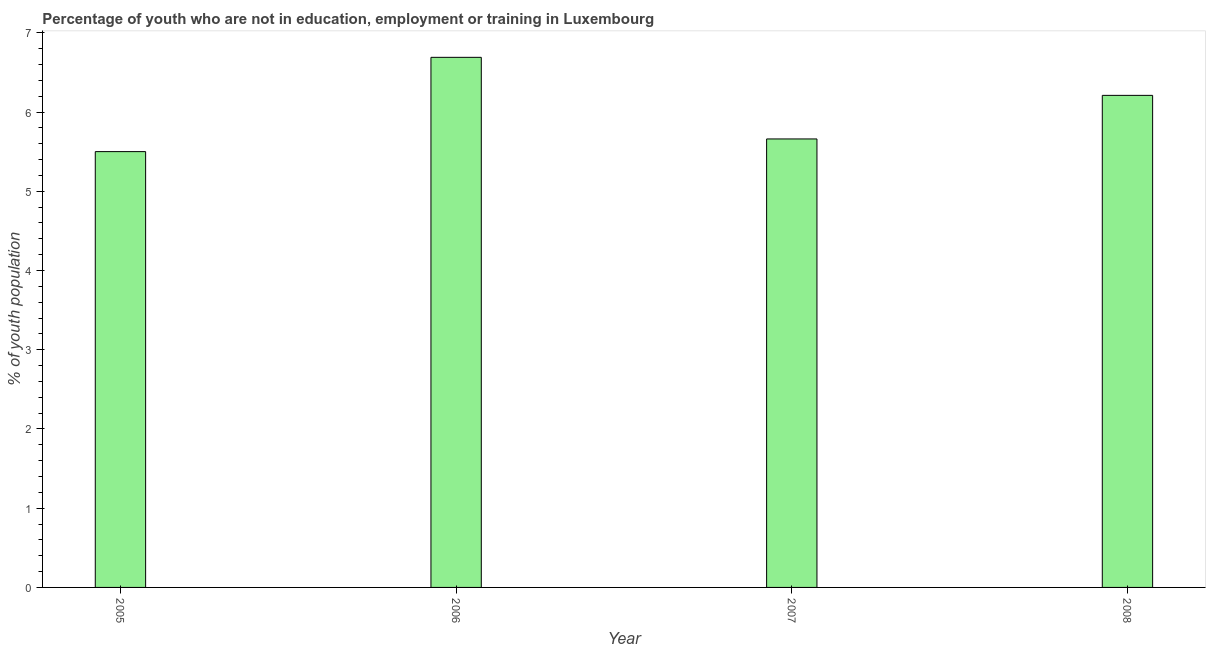Does the graph contain any zero values?
Your response must be concise. No. Does the graph contain grids?
Your answer should be very brief. No. What is the title of the graph?
Provide a short and direct response. Percentage of youth who are not in education, employment or training in Luxembourg. What is the label or title of the X-axis?
Ensure brevity in your answer.  Year. What is the label or title of the Y-axis?
Keep it short and to the point. % of youth population. What is the unemployed youth population in 2008?
Make the answer very short. 6.21. Across all years, what is the maximum unemployed youth population?
Your response must be concise. 6.69. In which year was the unemployed youth population minimum?
Offer a very short reply. 2005. What is the sum of the unemployed youth population?
Your response must be concise. 24.06. What is the difference between the unemployed youth population in 2006 and 2008?
Offer a terse response. 0.48. What is the average unemployed youth population per year?
Your answer should be compact. 6.01. What is the median unemployed youth population?
Give a very brief answer. 5.93. In how many years, is the unemployed youth population greater than 4.6 %?
Provide a succinct answer. 4. Do a majority of the years between 2008 and 2005 (inclusive) have unemployed youth population greater than 4.2 %?
Offer a very short reply. Yes. What is the ratio of the unemployed youth population in 2006 to that in 2008?
Provide a short and direct response. 1.08. Is the unemployed youth population in 2005 less than that in 2006?
Keep it short and to the point. Yes. Is the difference between the unemployed youth population in 2005 and 2006 greater than the difference between any two years?
Provide a short and direct response. Yes. What is the difference between the highest and the second highest unemployed youth population?
Offer a very short reply. 0.48. Is the sum of the unemployed youth population in 2007 and 2008 greater than the maximum unemployed youth population across all years?
Provide a succinct answer. Yes. What is the difference between the highest and the lowest unemployed youth population?
Give a very brief answer. 1.19. In how many years, is the unemployed youth population greater than the average unemployed youth population taken over all years?
Provide a short and direct response. 2. How many bars are there?
Offer a very short reply. 4. Are all the bars in the graph horizontal?
Your response must be concise. No. How many years are there in the graph?
Give a very brief answer. 4. What is the difference between two consecutive major ticks on the Y-axis?
Keep it short and to the point. 1. Are the values on the major ticks of Y-axis written in scientific E-notation?
Ensure brevity in your answer.  No. What is the % of youth population in 2006?
Keep it short and to the point. 6.69. What is the % of youth population in 2007?
Keep it short and to the point. 5.66. What is the % of youth population in 2008?
Provide a short and direct response. 6.21. What is the difference between the % of youth population in 2005 and 2006?
Your response must be concise. -1.19. What is the difference between the % of youth population in 2005 and 2007?
Your response must be concise. -0.16. What is the difference between the % of youth population in 2005 and 2008?
Offer a very short reply. -0.71. What is the difference between the % of youth population in 2006 and 2007?
Give a very brief answer. 1.03. What is the difference between the % of youth population in 2006 and 2008?
Offer a terse response. 0.48. What is the difference between the % of youth population in 2007 and 2008?
Your answer should be compact. -0.55. What is the ratio of the % of youth population in 2005 to that in 2006?
Offer a terse response. 0.82. What is the ratio of the % of youth population in 2005 to that in 2007?
Your answer should be compact. 0.97. What is the ratio of the % of youth population in 2005 to that in 2008?
Make the answer very short. 0.89. What is the ratio of the % of youth population in 2006 to that in 2007?
Keep it short and to the point. 1.18. What is the ratio of the % of youth population in 2006 to that in 2008?
Offer a very short reply. 1.08. What is the ratio of the % of youth population in 2007 to that in 2008?
Provide a short and direct response. 0.91. 